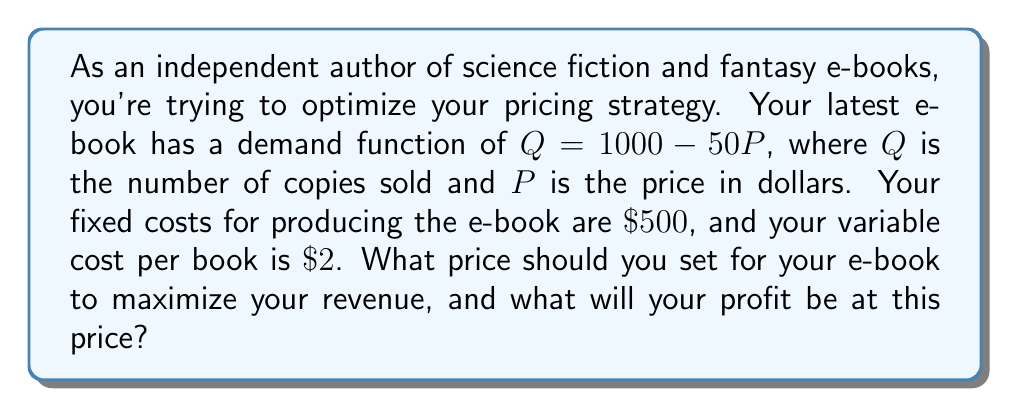Solve this math problem. To solve this problem, we'll follow these steps:

1) First, let's define our revenue function. Revenue is price times quantity:
   $R = PQ = P(1000 - 50P) = 1000P - 50P^2$

2) To find the price that maximizes revenue, we need to find the derivative of R with respect to P and set it to zero:
   $\frac{dR}{dP} = 1000 - 100P$
   Set this equal to zero:
   $1000 - 100P = 0$
   $100P = 1000$
   $P = 10$

3) The second derivative is negative ($-100$), confirming this is a maximum.

4) So, the revenue-maximizing price is $\$10$. At this price:
   $Q = 1000 - 50(10) = 500$ books sold

5) Now, let's calculate the profit at this price:
   Revenue = $10 * 500 = \$5000$
   Total Cost = Fixed Cost + (Variable Cost * Quantity)
               = $500 + (2 * 500) = \$1500$
   Profit = Revenue - Total Cost
          = $5000 - 1500 = \$3500$

Therefore, you should price your e-book at $\$10$ to maximize revenue, and at this price, your profit will be $\$3500$.
Answer: Price: $\$10$
Profit: $\$3500$ 